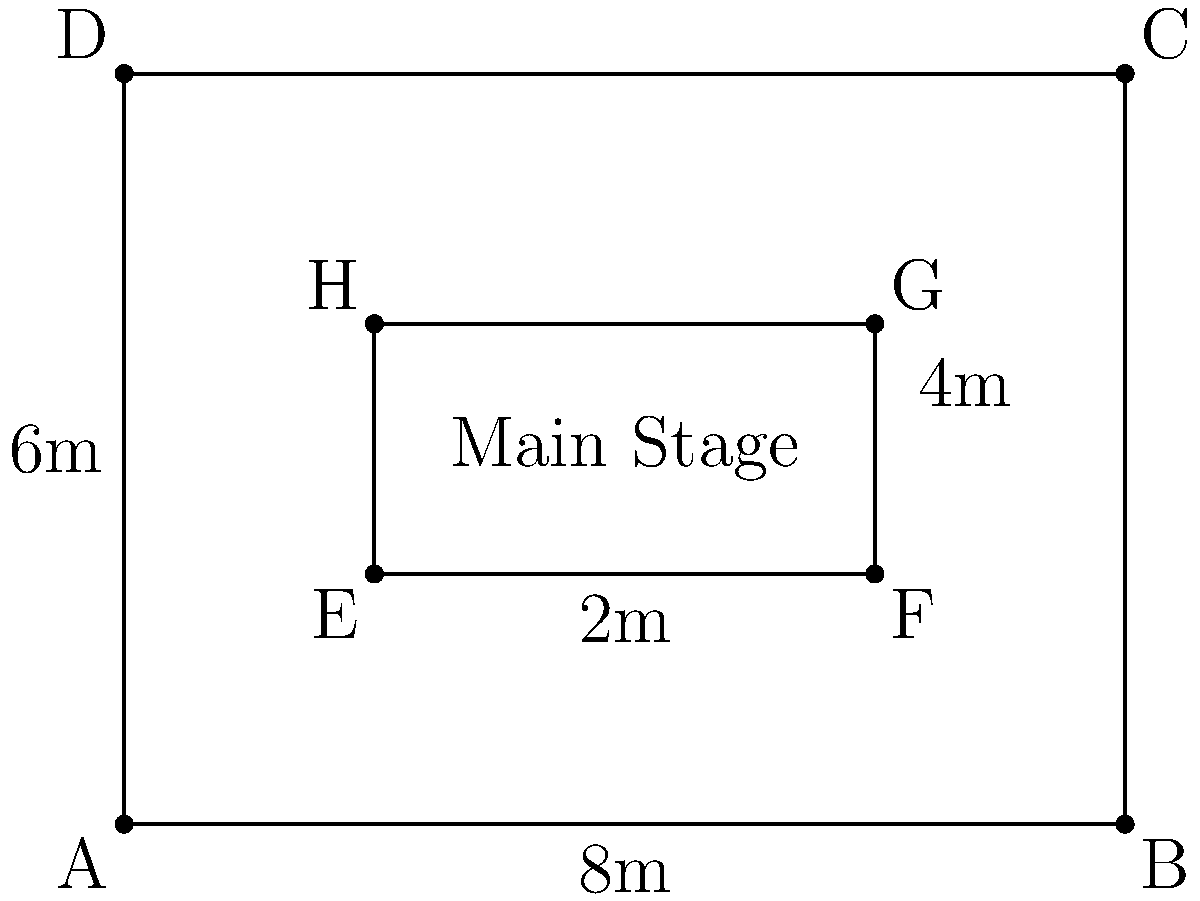For an upcoming Yola Araújo concert featuring traditional Angolan dance, you need to calculate the area of the main stage. Given the floor plan diagram, what is the area of the main stage in square meters? To calculate the area of the main stage, we need to follow these steps:

1. Identify the shape of the main stage:
   The main stage is represented by the inner rectangle EFGH.

2. Find the dimensions of the main stage:
   - Width: The distance between points E and F (or H and G) is 4m.
   - Length: The distance between points E and H (or F and G) is 2m.

3. Calculate the area using the formula for a rectangle:
   $$ \text{Area} = \text{length} \times \text{width} $$
   $$ \text{Area} = 4\text{m} \times 2\text{m} = 8\text{m}^2 $$

Therefore, the area of the main stage is 8 square meters.
Answer: $8\text{m}^2$ 